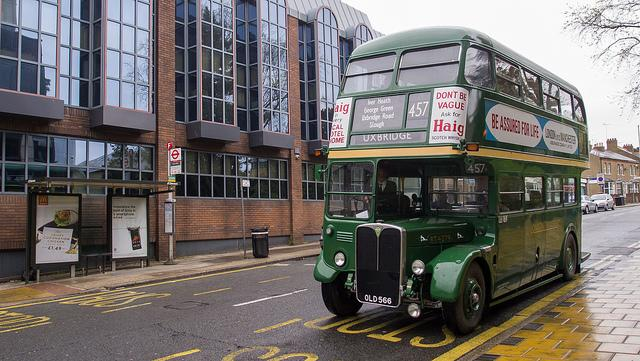What type of infrastructure does this city avoid having? Please explain your reasoning. low overpasses. The infrastructure has overpasses. 